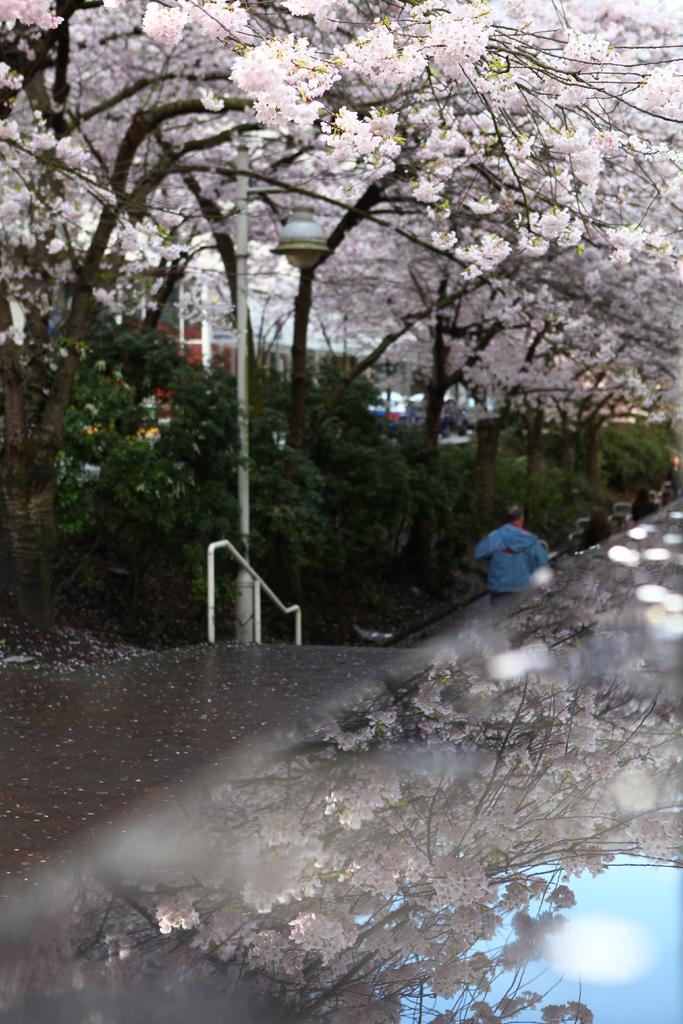In one or two sentences, can you explain what this image depicts? This image is taken outdoors. At the top of the image there are many trees with pink colored flowers. There are a few plants with green leaves and stems. In the middle of the image there is a pole with a street light and there is a railing. There is a road and there is a man. At the bottom of the image there is a reflection of flowers, trees and the sky. 